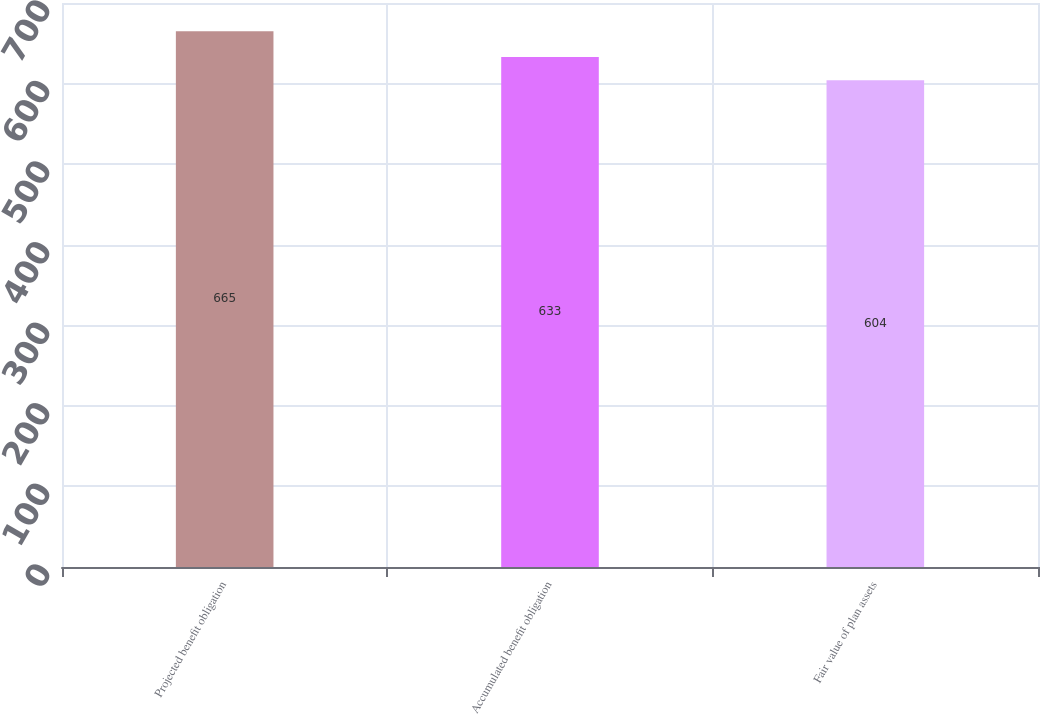<chart> <loc_0><loc_0><loc_500><loc_500><bar_chart><fcel>Projected benefit obligation<fcel>Accumulated benefit obligation<fcel>Fair value of plan assets<nl><fcel>665<fcel>633<fcel>604<nl></chart> 